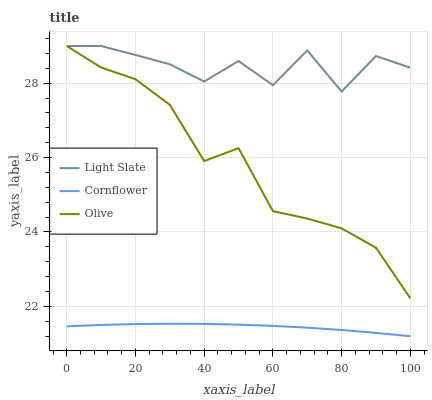Does Olive have the minimum area under the curve?
Answer yes or no. No. Does Olive have the maximum area under the curve?
Answer yes or no. No. Is Olive the smoothest?
Answer yes or no. No. Is Olive the roughest?
Answer yes or no. No. Does Olive have the lowest value?
Answer yes or no. No. Does Cornflower have the highest value?
Answer yes or no. No. Is Cornflower less than Olive?
Answer yes or no. Yes. Is Olive greater than Cornflower?
Answer yes or no. Yes. Does Cornflower intersect Olive?
Answer yes or no. No. 